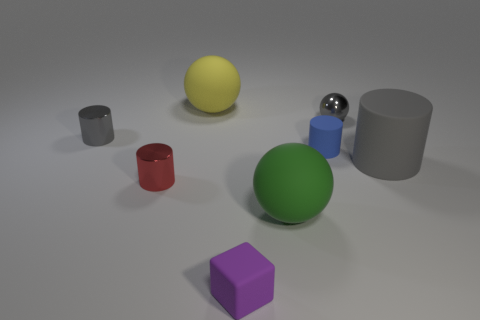What lighting conditions are depicted in the image? The lighting in the image suggests a diffused overhead source, casting soft shadows directly underneath the objects. The shadows are not very stark or long, which implies the light source is neither too close to the objects nor exceptionally intense. The overall illumination is even, indicating that the environment is likely to be an indoor setup with controlled lighting, creating a subtle ambience ideal for highlighting the objects without causing harsh reflections or deep shadows. 